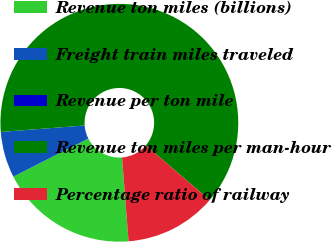<chart> <loc_0><loc_0><loc_500><loc_500><pie_chart><fcel>Revenue ton miles (billions)<fcel>Freight train miles traveled<fcel>Revenue per ton mile<fcel>Revenue ton miles per man-hour<fcel>Percentage ratio of railway<nl><fcel>18.75%<fcel>6.25%<fcel>0.0%<fcel>62.5%<fcel>12.5%<nl></chart> 